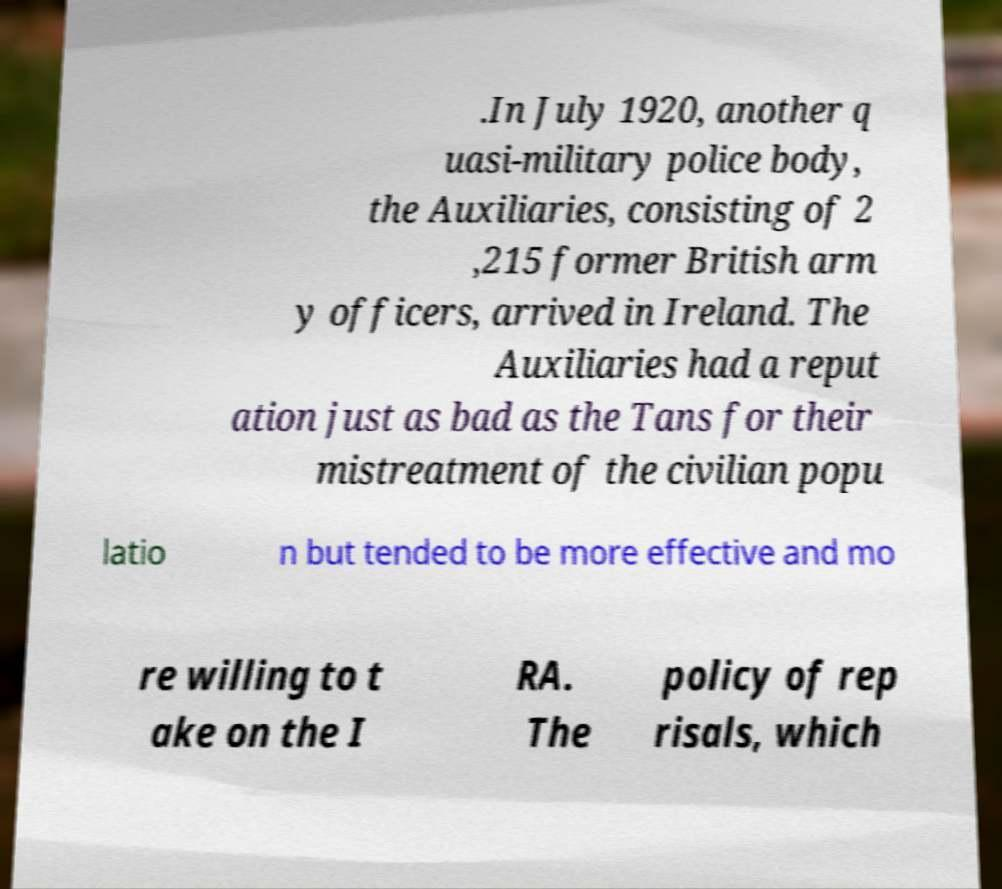Please identify and transcribe the text found in this image. .In July 1920, another q uasi-military police body, the Auxiliaries, consisting of 2 ,215 former British arm y officers, arrived in Ireland. The Auxiliaries had a reput ation just as bad as the Tans for their mistreatment of the civilian popu latio n but tended to be more effective and mo re willing to t ake on the I RA. The policy of rep risals, which 